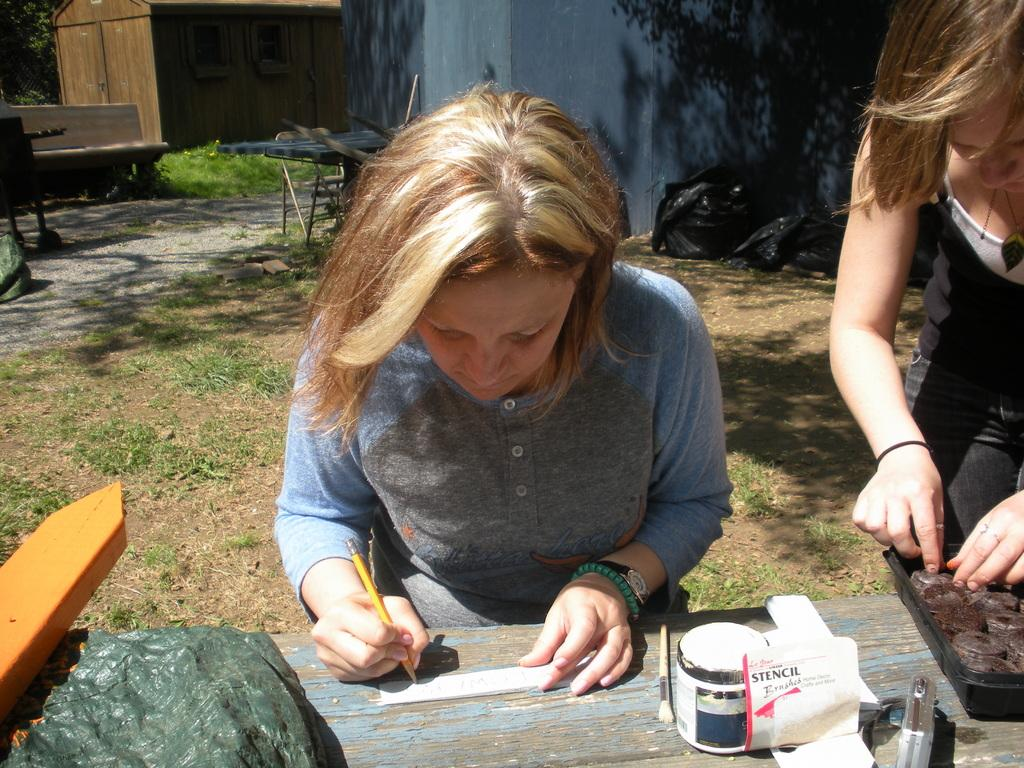Who is the main subject in the image? There is a girl in the center of the image. What is the girl in the center doing? The girl is writing. Are there any other people in the image? Yes, there is another girl on the right side of the image. What can be seen in the background of the image? There is a house at the top side of the image. Can you hear the giraffe laughing in the image? There is no giraffe present in the image, and therefore, it cannot be heard laughing. 